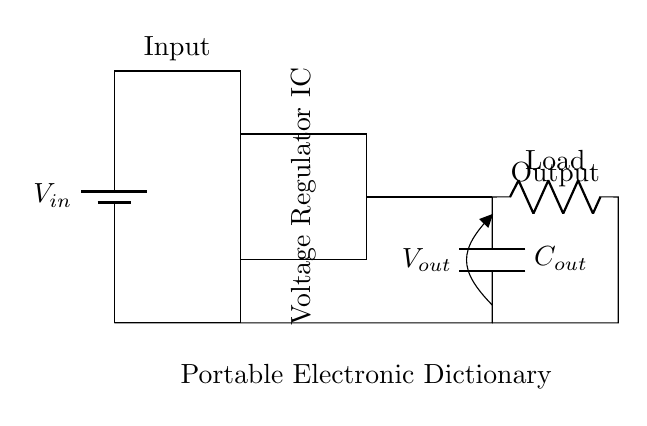What is the function of the voltage regulator IC? The voltage regulator IC maintains a constant output voltage despite variations in input voltage and load conditions. In this circuit, it is crucial for providing stable power to the portable electronic dictionary.
Answer: maintain constant output voltage What is the value of the load in the circuit? The load is represented in the circuit as "Load," indicating that it is an unspecified resistive load connected to the output of the voltage regulator. Its value can vary based on the specific application.
Answer: Load What is the role of the output capacitor? The output capacitor, denoted as Cout, smooths the voltage output by reducing voltage fluctuations, ensuring stable operation of the connected load, and improving transient response.
Answer: smooth voltage output What are the input and output voltages in the circuit? The input voltage is given as Vin, and the output voltage is Vout. The specific numerical values are not provided in the diagram, but these reflect the voltage levels before the regulator and after regulation respectively.
Answer: Vin and Vout Where does the input voltage originate? The input voltage comes from a battery, as indicated by the battery symbol in the circuit diagram at the start of the circuit chain. This serves as the power source for the voltage regulator.
Answer: battery What does the portable electronic dictionary require in terms of voltage? The portable electronic dictionary requires a stable voltage from the voltage regulator to function correctly; however, the exact voltage specification is not detailed in the provided diagram.
Answer: stable voltage How can variations in input voltage affect the circuit's performance? Variations in input voltage can lead to fluctuations in output voltage if not regulated, potentially destabilizing the operation of the portable electronic dictionary. The voltage regulator IC is designed to counteract these variations.
Answer: destabilize operation 